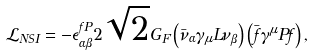Convert formula to latex. <formula><loc_0><loc_0><loc_500><loc_500>\mathcal { L } _ { N S I } = - \epsilon _ { \alpha \beta } ^ { f P } 2 \sqrt { 2 } G _ { F } \left ( \bar { \nu } _ { \alpha } \gamma _ { \mu } L \nu _ { \beta } \right ) \left ( \bar { f } \gamma ^ { \mu } P f \right ) ,</formula> 